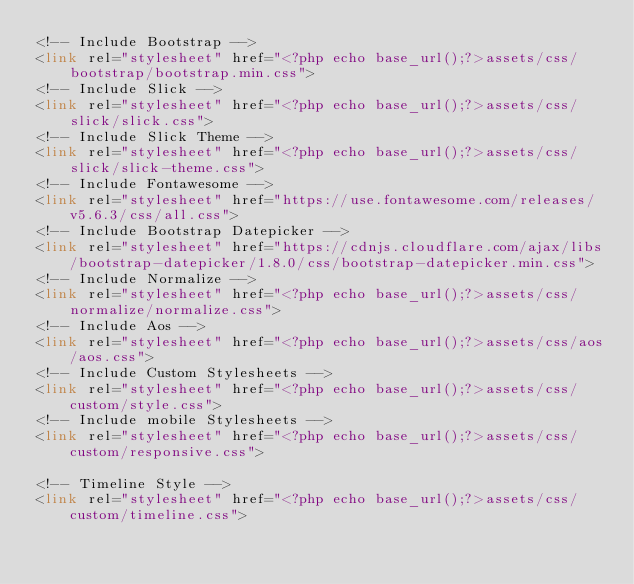<code> <loc_0><loc_0><loc_500><loc_500><_PHP_><!-- Include Bootstrap -->
<link rel="stylesheet" href="<?php echo base_url();?>assets/css/bootstrap/bootstrap.min.css">
<!-- Include Slick -->
<link rel="stylesheet" href="<?php echo base_url();?>assets/css/slick/slick.css">
<!-- Include Slick Theme -->
<link rel="stylesheet" href="<?php echo base_url();?>assets/css/slick/slick-theme.css">
<!-- Include Fontawesome -->
<link rel="stylesheet" href="https://use.fontawesome.com/releases/v5.6.3/css/all.css">
<!-- Include Bootstrap Datepicker -->
<link rel="stylesheet" href="https://cdnjs.cloudflare.com/ajax/libs/bootstrap-datepicker/1.8.0/css/bootstrap-datepicker.min.css">
<!-- Include Normalize -->
<link rel="stylesheet" href="<?php echo base_url();?>assets/css/normalize/normalize.css">
<!-- Include Aos -->
<link rel="stylesheet" href="<?php echo base_url();?>assets/css/aos/aos.css">
<!-- Include Custom Stylesheets -->
<link rel="stylesheet" href="<?php echo base_url();?>assets/css/custom/style.css">
<!-- Include mobile Stylesheets -->
<link rel="stylesheet" href="<?php echo base_url();?>assets/css/custom/responsive.css">

<!-- Timeline Style -->
<link rel="stylesheet" href="<?php echo base_url();?>assets/css/custom/timeline.css"></code> 